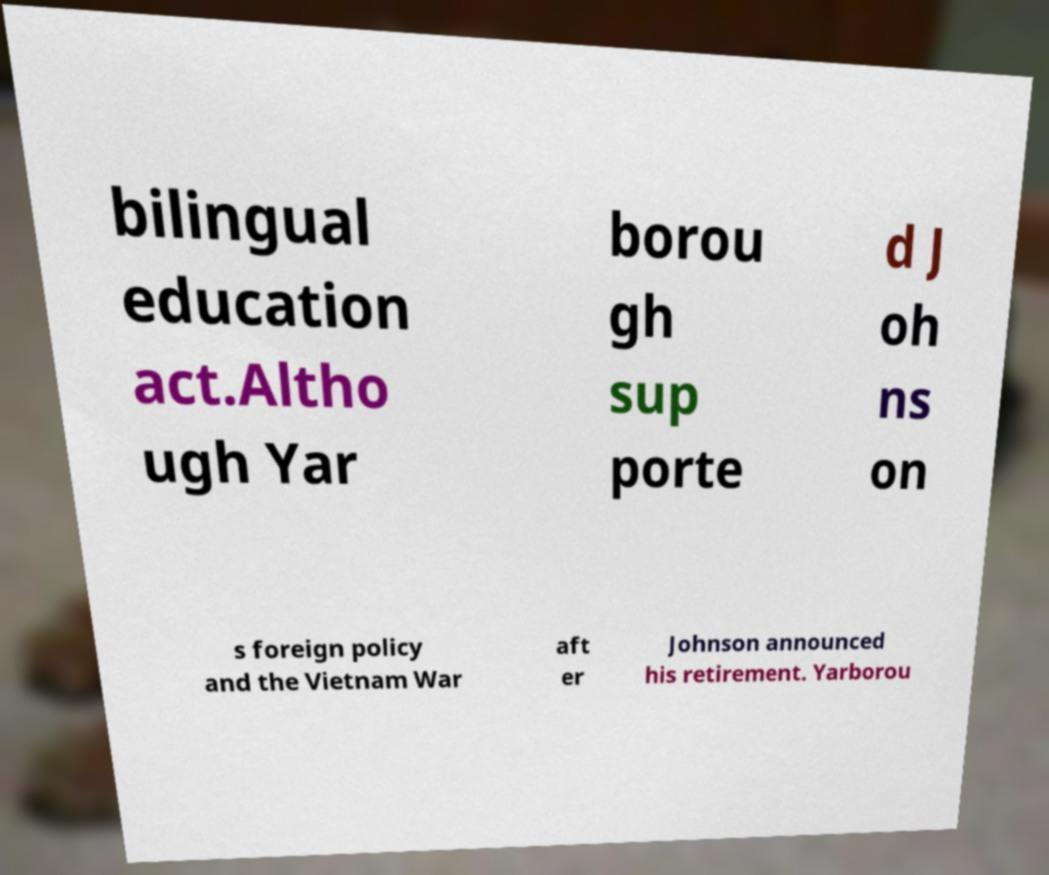What messages or text are displayed in this image? I need them in a readable, typed format. bilingual education act.Altho ugh Yar borou gh sup porte d J oh ns on s foreign policy and the Vietnam War aft er Johnson announced his retirement. Yarborou 